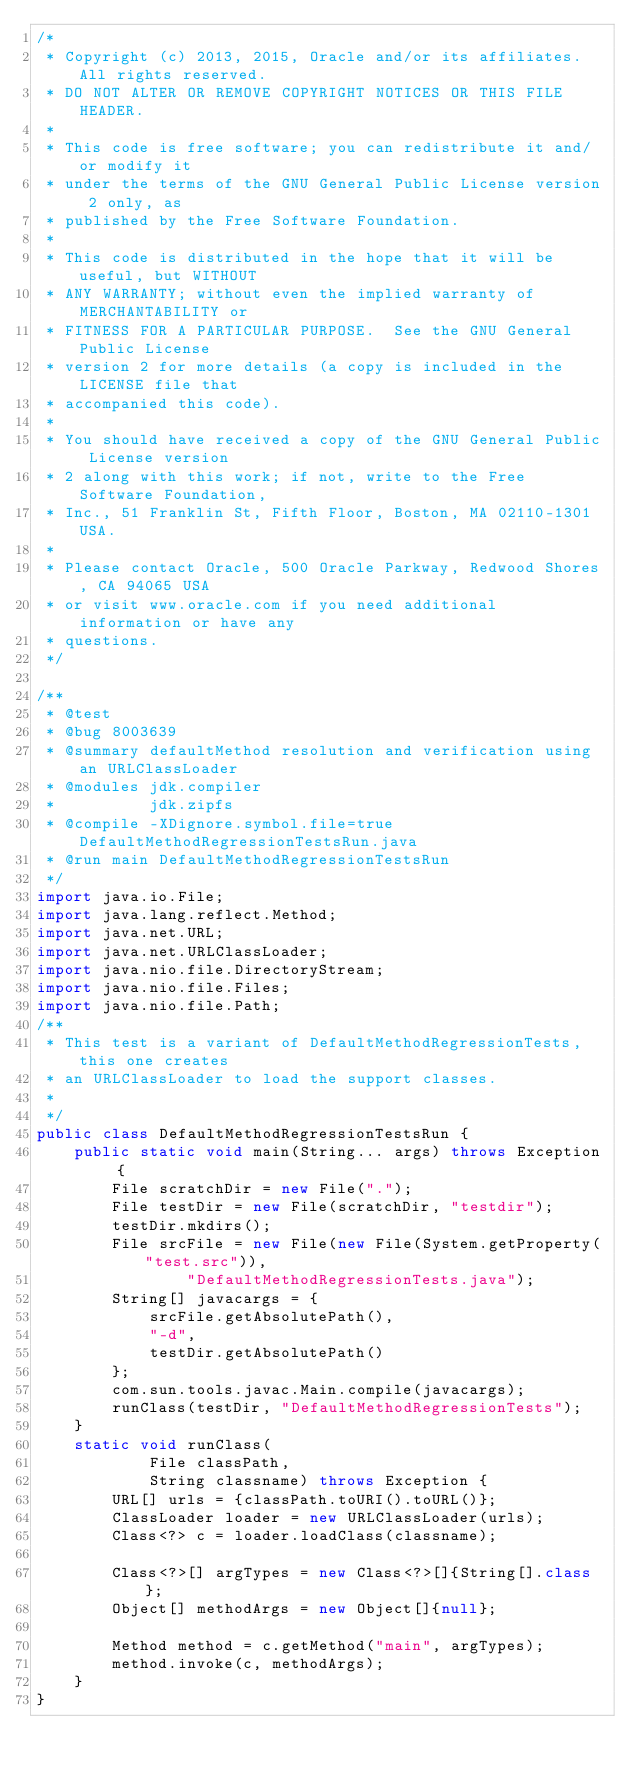Convert code to text. <code><loc_0><loc_0><loc_500><loc_500><_Java_>/*
 * Copyright (c) 2013, 2015, Oracle and/or its affiliates. All rights reserved.
 * DO NOT ALTER OR REMOVE COPYRIGHT NOTICES OR THIS FILE HEADER.
 *
 * This code is free software; you can redistribute it and/or modify it
 * under the terms of the GNU General Public License version 2 only, as
 * published by the Free Software Foundation.
 *
 * This code is distributed in the hope that it will be useful, but WITHOUT
 * ANY WARRANTY; without even the implied warranty of MERCHANTABILITY or
 * FITNESS FOR A PARTICULAR PURPOSE.  See the GNU General Public License
 * version 2 for more details (a copy is included in the LICENSE file that
 * accompanied this code).
 *
 * You should have received a copy of the GNU General Public License version
 * 2 along with this work; if not, write to the Free Software Foundation,
 * Inc., 51 Franklin St, Fifth Floor, Boston, MA 02110-1301 USA.
 *
 * Please contact Oracle, 500 Oracle Parkway, Redwood Shores, CA 94065 USA
 * or visit www.oracle.com if you need additional information or have any
 * questions.
 */

/**
 * @test
 * @bug 8003639
 * @summary defaultMethod resolution and verification using an URLClassLoader
 * @modules jdk.compiler
 *          jdk.zipfs
 * @compile -XDignore.symbol.file=true DefaultMethodRegressionTestsRun.java
 * @run main DefaultMethodRegressionTestsRun
 */
import java.io.File;
import java.lang.reflect.Method;
import java.net.URL;
import java.net.URLClassLoader;
import java.nio.file.DirectoryStream;
import java.nio.file.Files;
import java.nio.file.Path;
/**
 * This test is a variant of DefaultMethodRegressionTests, this one creates
 * an URLClassLoader to load the support classes.
 *
 */
public class DefaultMethodRegressionTestsRun {
    public static void main(String... args) throws Exception {
        File scratchDir = new File(".");
        File testDir = new File(scratchDir, "testdir");
        testDir.mkdirs();
        File srcFile = new File(new File(System.getProperty("test.src")),
                "DefaultMethodRegressionTests.java");
        String[] javacargs = {
            srcFile.getAbsolutePath(),
            "-d",
            testDir.getAbsolutePath()
        };
        com.sun.tools.javac.Main.compile(javacargs);
        runClass(testDir, "DefaultMethodRegressionTests");
    }
    static void runClass(
            File classPath,
            String classname) throws Exception {
        URL[] urls = {classPath.toURI().toURL()};
        ClassLoader loader = new URLClassLoader(urls);
        Class<?> c = loader.loadClass(classname);

        Class<?>[] argTypes = new Class<?>[]{String[].class};
        Object[] methodArgs = new Object[]{null};

        Method method = c.getMethod("main", argTypes);
        method.invoke(c, methodArgs);
    }
}
</code> 